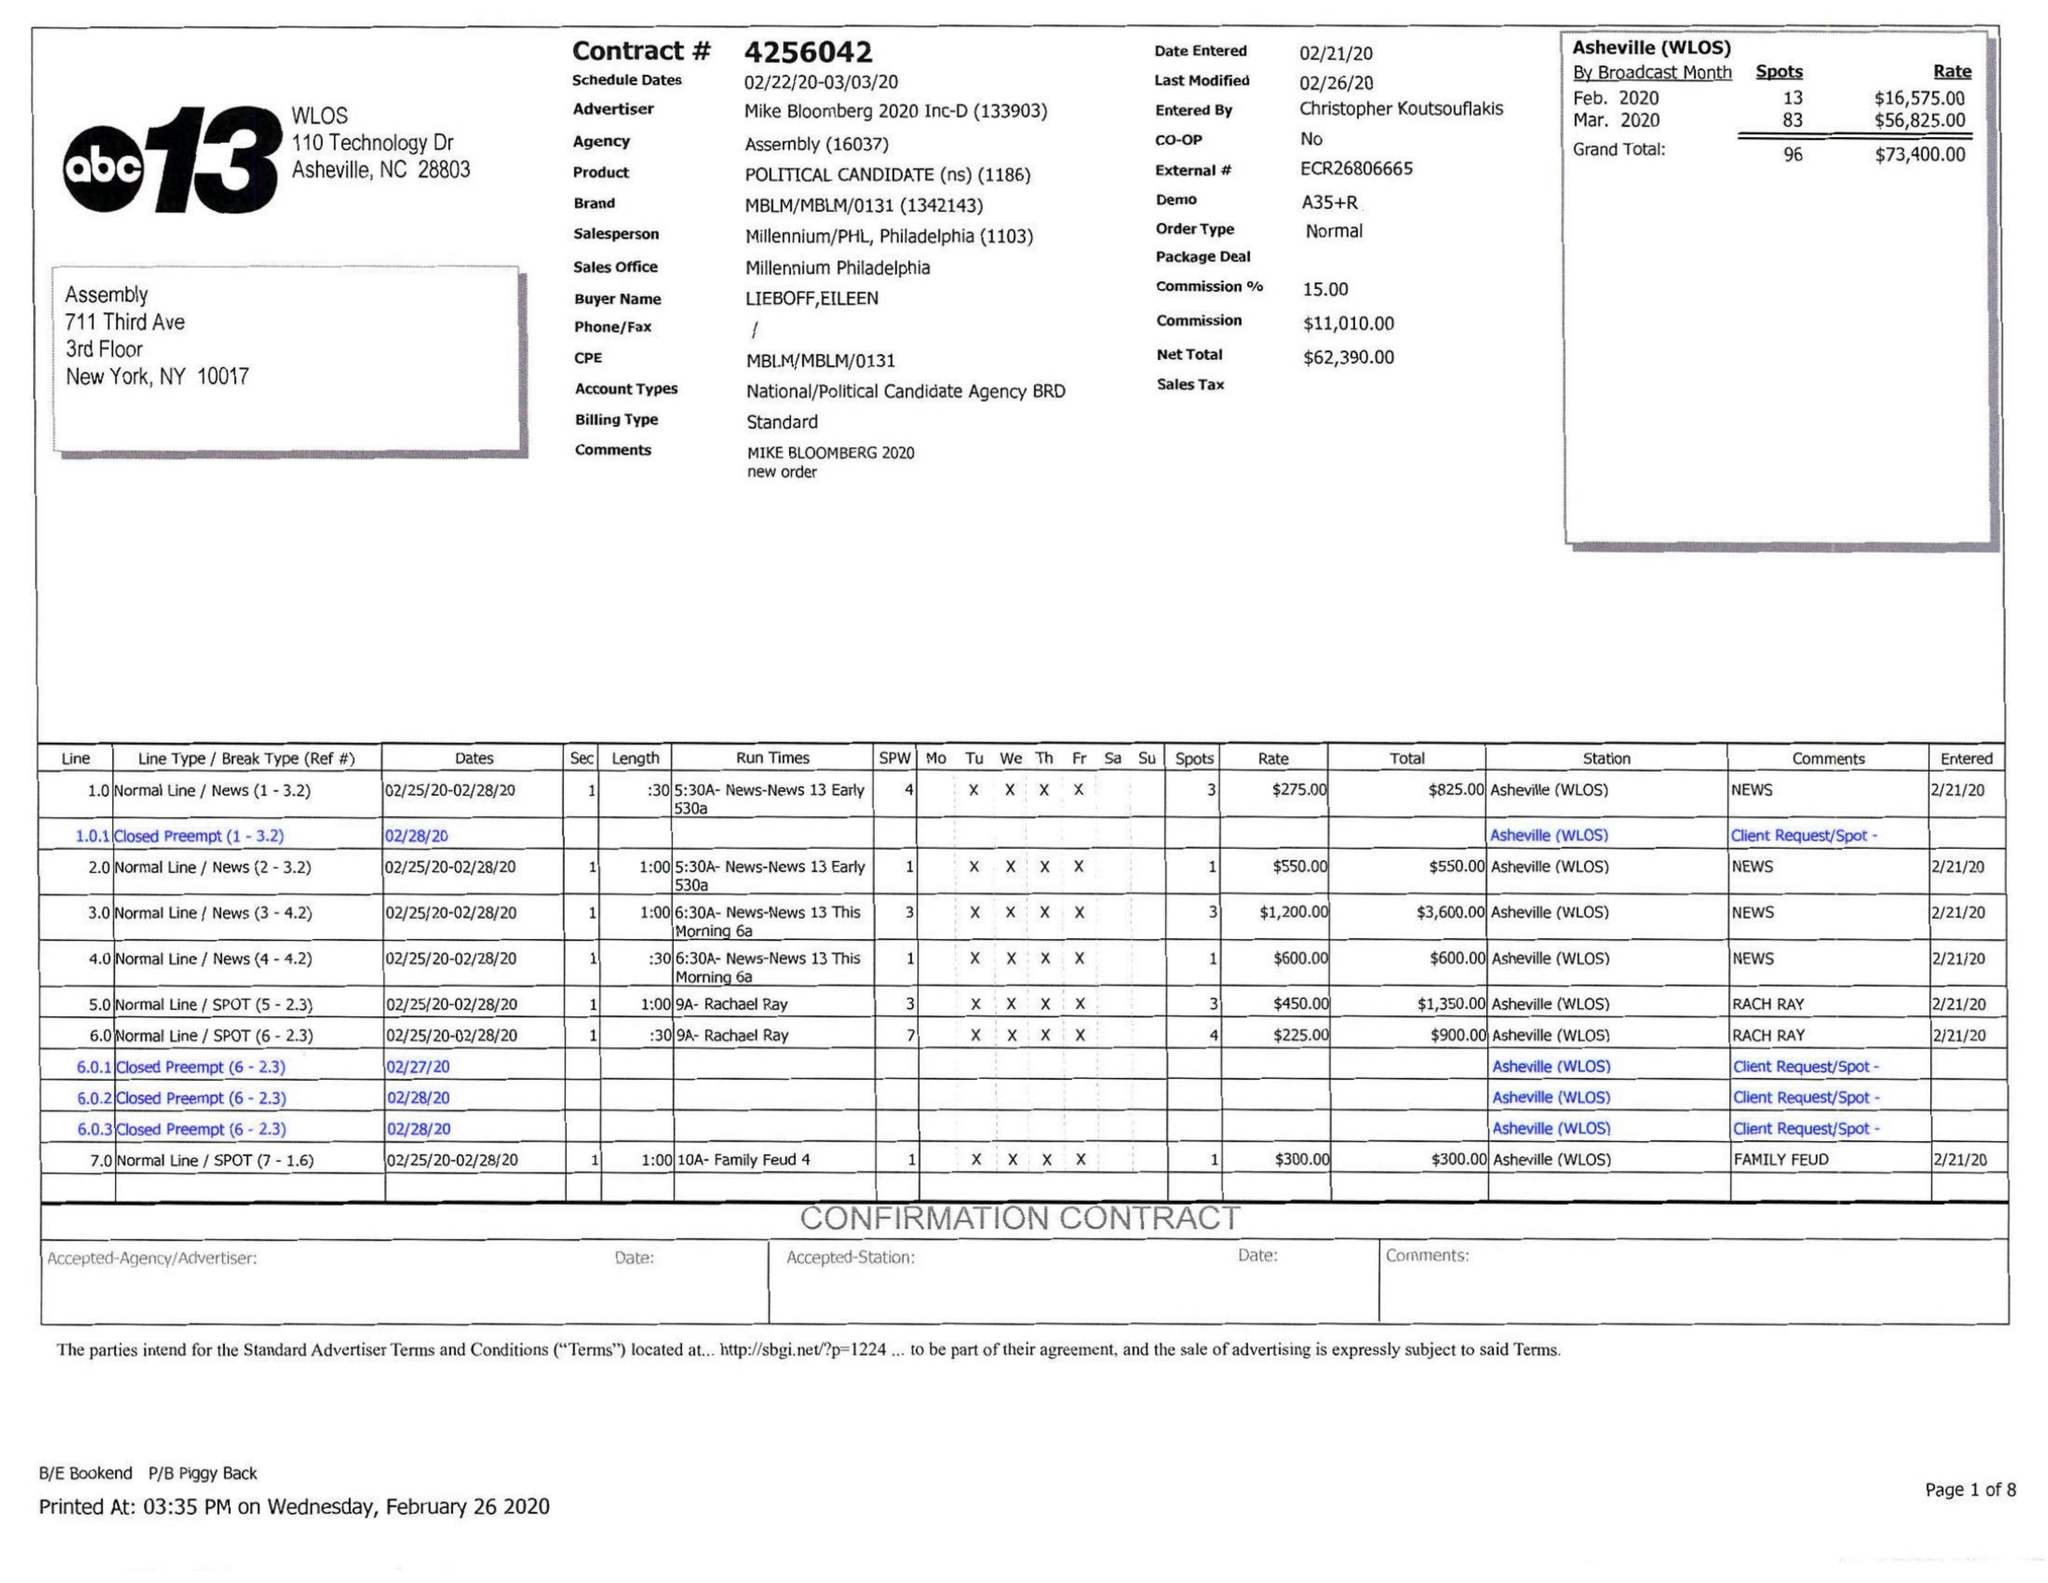What is the value for the flight_from?
Answer the question using a single word or phrase. 02/22/20 